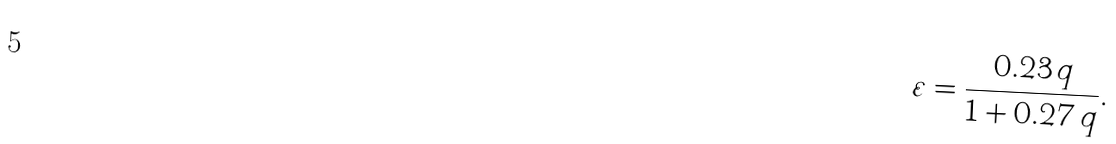<formula> <loc_0><loc_0><loc_500><loc_500>\varepsilon = \frac { 0 . 2 3 \, q } { 1 + 0 . 2 7 \, q } .</formula> 